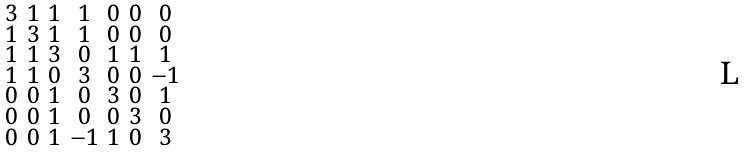Convert formula to latex. <formula><loc_0><loc_0><loc_500><loc_500>\begin{smallmatrix} 3 & 1 & 1 & 1 & 0 & 0 & 0 \\ 1 & 3 & 1 & 1 & 0 & 0 & 0 \\ 1 & 1 & 3 & 0 & 1 & 1 & 1 \\ 1 & 1 & 0 & 3 & 0 & 0 & - 1 \\ 0 & 0 & 1 & 0 & 3 & 0 & 1 \\ 0 & 0 & 1 & 0 & 0 & 3 & 0 \\ 0 & 0 & 1 & - 1 & 1 & 0 & 3 \end{smallmatrix}</formula> 